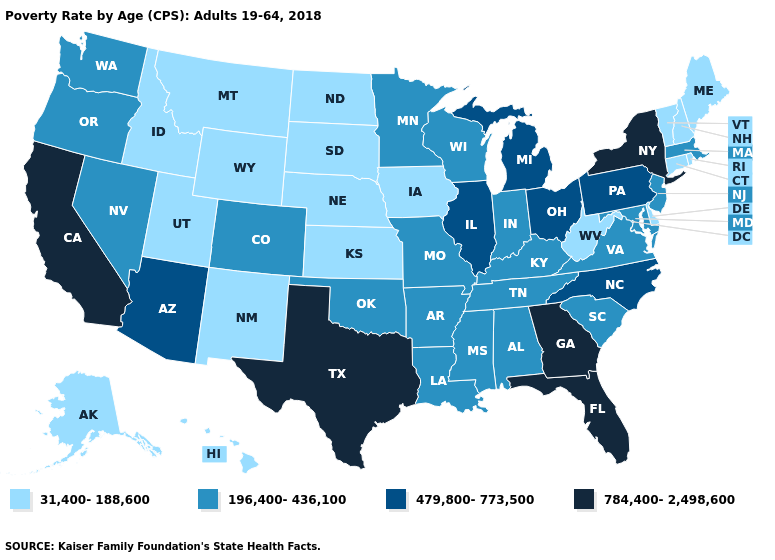Does South Carolina have the highest value in the USA?
Write a very short answer. No. Among the states that border Massachusetts , does New York have the highest value?
Be succinct. Yes. Does Missouri have a lower value than New Hampshire?
Quick response, please. No. What is the value of Indiana?
Short answer required. 196,400-436,100. Name the states that have a value in the range 31,400-188,600?
Write a very short answer. Alaska, Connecticut, Delaware, Hawaii, Idaho, Iowa, Kansas, Maine, Montana, Nebraska, New Hampshire, New Mexico, North Dakota, Rhode Island, South Dakota, Utah, Vermont, West Virginia, Wyoming. What is the value of Mississippi?
Answer briefly. 196,400-436,100. Name the states that have a value in the range 196,400-436,100?
Keep it brief. Alabama, Arkansas, Colorado, Indiana, Kentucky, Louisiana, Maryland, Massachusetts, Minnesota, Mississippi, Missouri, Nevada, New Jersey, Oklahoma, Oregon, South Carolina, Tennessee, Virginia, Washington, Wisconsin. Among the states that border Florida , which have the lowest value?
Write a very short answer. Alabama. Does the map have missing data?
Answer briefly. No. Among the states that border Montana , which have the lowest value?
Keep it brief. Idaho, North Dakota, South Dakota, Wyoming. Name the states that have a value in the range 196,400-436,100?
Concise answer only. Alabama, Arkansas, Colorado, Indiana, Kentucky, Louisiana, Maryland, Massachusetts, Minnesota, Mississippi, Missouri, Nevada, New Jersey, Oklahoma, Oregon, South Carolina, Tennessee, Virginia, Washington, Wisconsin. What is the highest value in states that border Alabama?
Short answer required. 784,400-2,498,600. Among the states that border Massachusetts , does New York have the lowest value?
Keep it brief. No. What is the value of Virginia?
Concise answer only. 196,400-436,100. Among the states that border Pennsylvania , which have the lowest value?
Concise answer only. Delaware, West Virginia. 